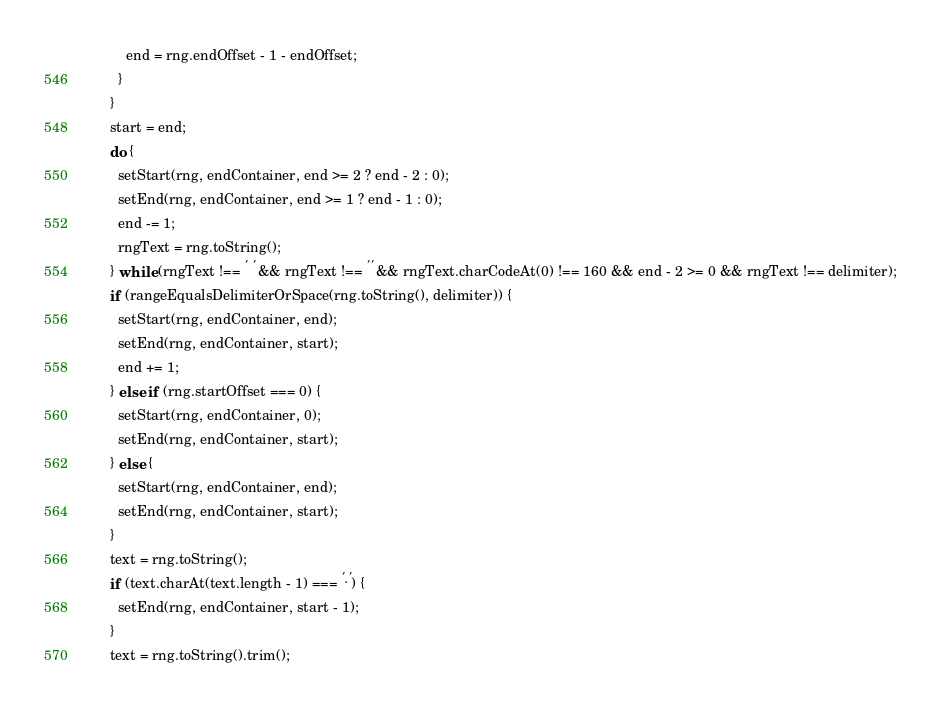<code> <loc_0><loc_0><loc_500><loc_500><_JavaScript_>          end = rng.endOffset - 1 - endOffset;
        }
      }
      start = end;
      do {
        setStart(rng, endContainer, end >= 2 ? end - 2 : 0);
        setEnd(rng, endContainer, end >= 1 ? end - 1 : 0);
        end -= 1;
        rngText = rng.toString();
      } while (rngText !== ' ' && rngText !== '' && rngText.charCodeAt(0) !== 160 && end - 2 >= 0 && rngText !== delimiter);
      if (rangeEqualsDelimiterOrSpace(rng.toString(), delimiter)) {
        setStart(rng, endContainer, end);
        setEnd(rng, endContainer, start);
        end += 1;
      } else if (rng.startOffset === 0) {
        setStart(rng, endContainer, 0);
        setEnd(rng, endContainer, start);
      } else {
        setStart(rng, endContainer, end);
        setEnd(rng, endContainer, start);
      }
      text = rng.toString();
      if (text.charAt(text.length - 1) === '.') {
        setEnd(rng, endContainer, start - 1);
      }
      text = rng.toString().trim();</code> 